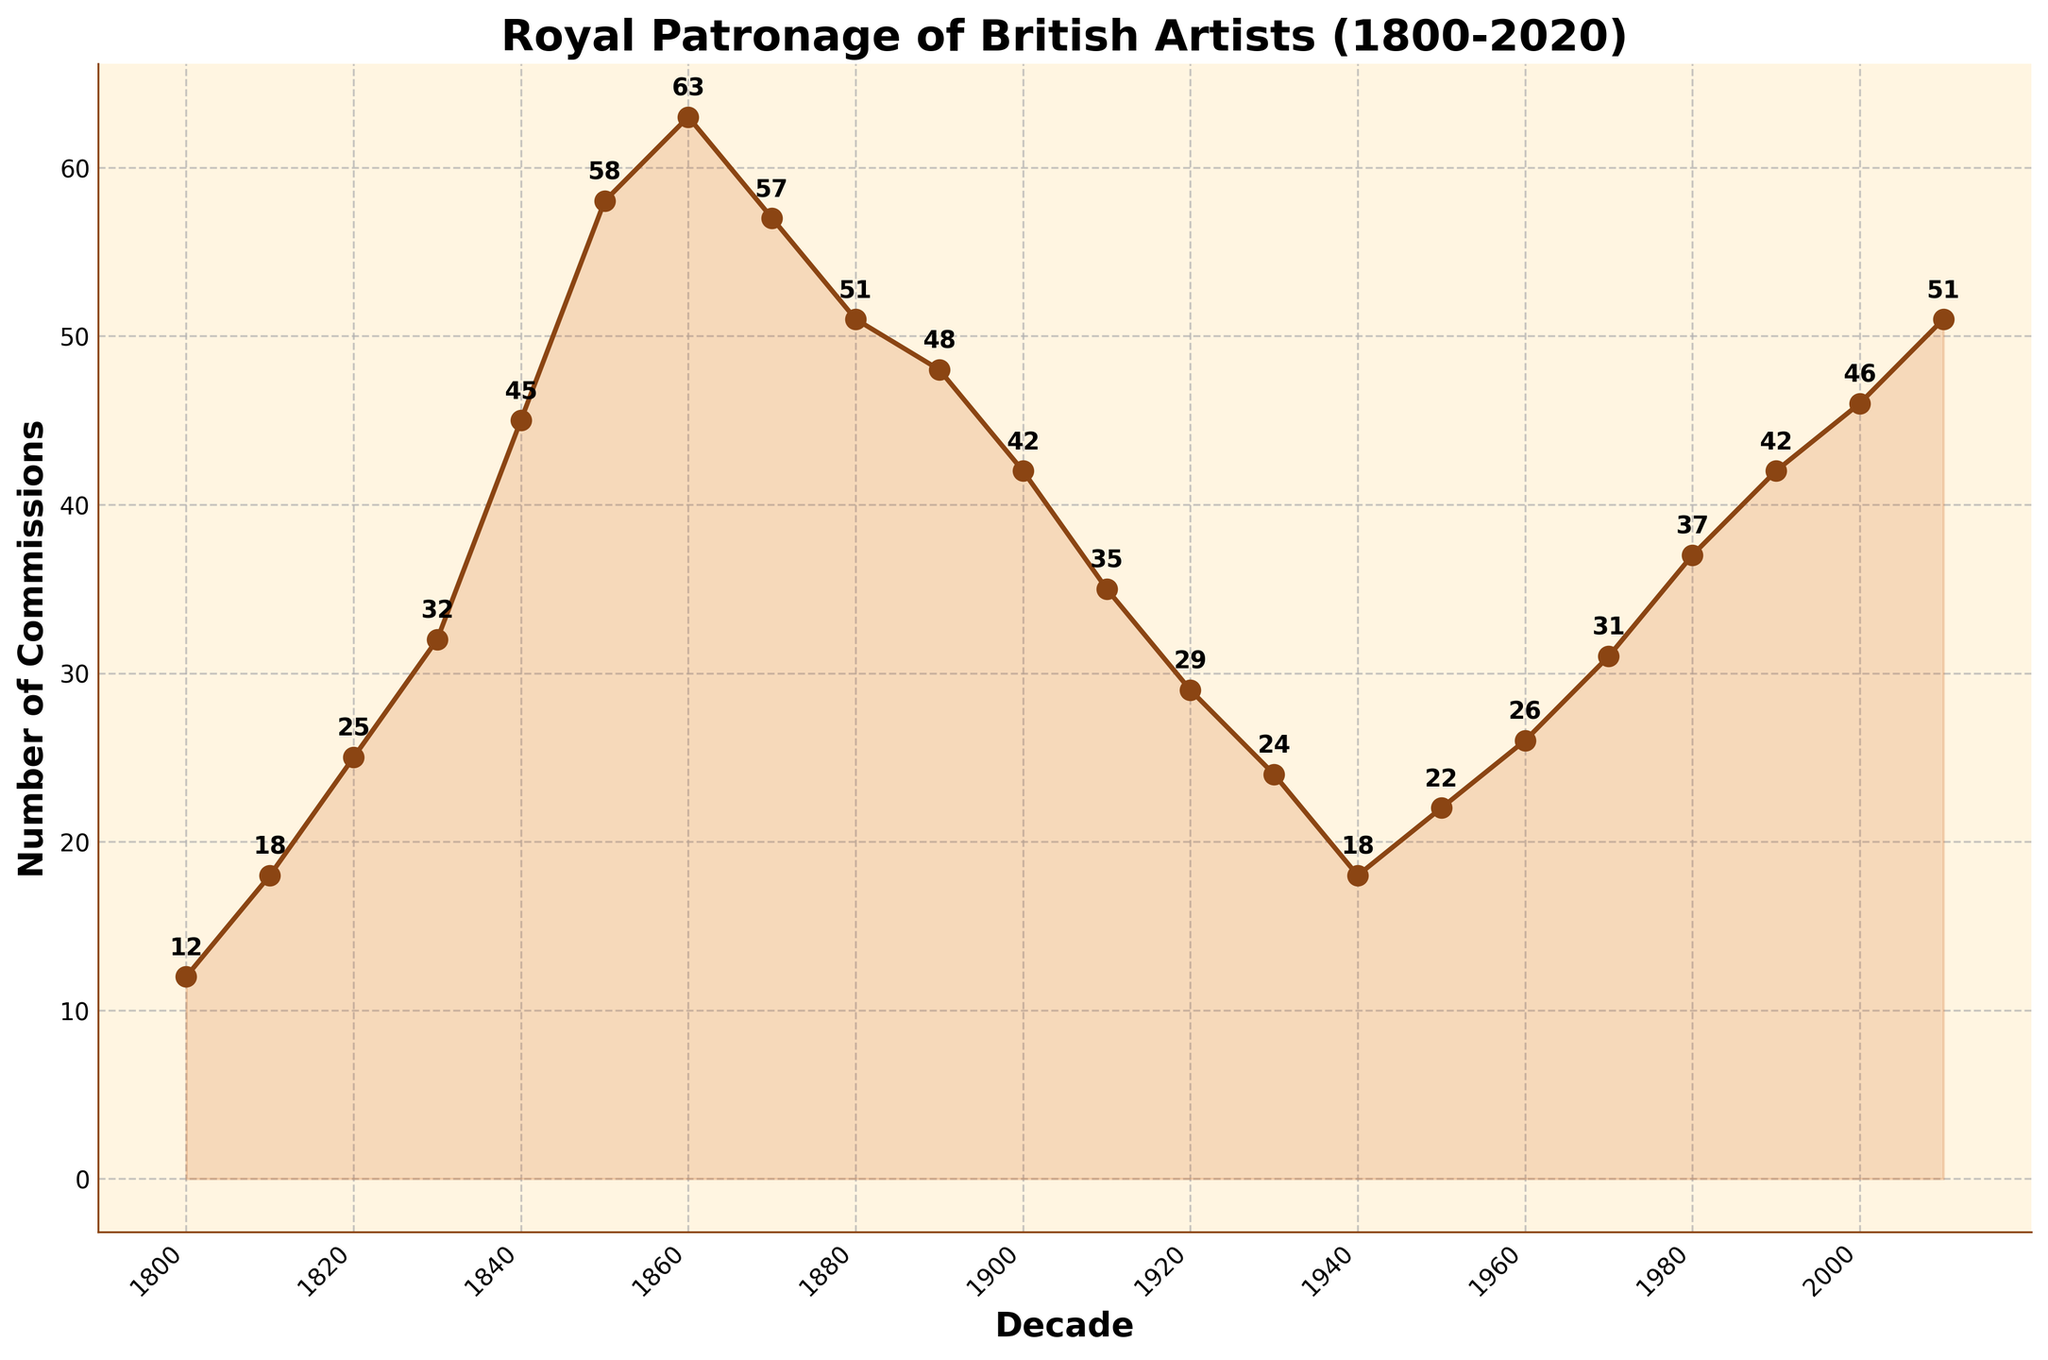What is the decade with the highest number of commissions? The highest point on the line chart represents the peak number of commissions. This point occurs at the decade between 1860 and 1870.
Answer: 1860-1870 What is the difference in the number of commissions between 1840-1850 and 1850-1860? Identify the number of commissions for the two decades: 45 (1840-1850) and 58 (1850-1860). The difference is 58 - 45 = 13.
Answer: 13 What was the trend in the number of commissions from 1900-1910 to 1940-1950? Observe the line plot from 1900-1910 to 1940-1950, noticing the trend goes from 42 down to 18. The overall trend is a decrease.
Answer: Decreasing Between which two consecutive decades did the number of commissions increase the most? Compare the differences between each consecutive decade: the greatest difference is between 1840-1850 and 1850-1860, where the number of commissions increased from 45 to 58, a difference of 13.
Answer: 1840-1850 and 1850-1860 What was the average number of commissions per decade from 1800 to 1900? Sum the commissions for the decades from 1800 to 1900: 12+18+25+32+45+58+63+57+51+48 = 409. There are 10 decades, so the average is 409/10 = 40.9.
Answer: 40.9 Which two decades have the same number of commissions, and what is that number? Looking at the plot, 1900-1910 and 1990-2000 both have 42 commissions.
Answer: 1900-1910 and 1990-2000, 42 How many more commissions were there in 2010-2020 compared to 2000-2010? Compare the numbers: 51 (2010-2020) and 46 (2000-2010). The difference is 51 - 46 = 5.
Answer: 5 What is the general trend in the number of commissions from 1950 to 2020? Observing the trend from 1950-1960 through 2010-2020, the line generally trends upward, indicating an increase in commissions throughout these decades.
Answer: Increasing How does the number of commissions in the decade 1830-1840 compare to the decade 1930-1940? The number of commissions in 1830-1840 is 32, whereas in 1930-1940 it is 24. Thus, 1830-1840 had more commissions.
Answer: 1830-1840 had more What is the median number of commissions for the entire period? List the commissions in ascending order: 12, 18, 18, 22, 24, 25, 26, 29, 31, 32, 35, 37, 42, 42, 45, 46, 48, 51, 51, 57, 58, 63. The median of 22 terms is the average of the 11th and 12th terms: (35+37)/2 = 36.
Answer: 36 